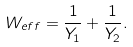<formula> <loc_0><loc_0><loc_500><loc_500>W _ { e f f } = \frac { 1 } { Y _ { 1 } } + \frac { 1 } { Y _ { 2 } } .</formula> 